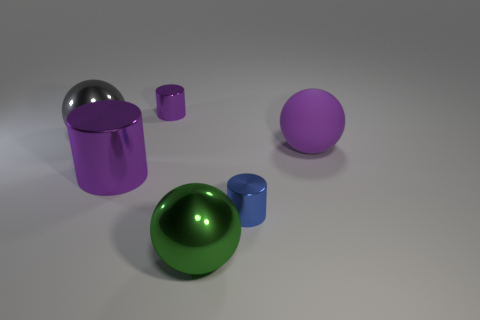Subtract all large green balls. How many balls are left? 2 Subtract all gray spheres. How many spheres are left? 2 Add 4 big purple things. How many objects exist? 10 Subtract 2 spheres. How many spheres are left? 1 Subtract all gray cubes. How many purple cylinders are left? 2 Add 4 tiny purple shiny cylinders. How many tiny purple shiny cylinders are left? 5 Add 1 purple matte objects. How many purple matte objects exist? 2 Subtract 0 red cubes. How many objects are left? 6 Subtract all gray balls. Subtract all red cubes. How many balls are left? 2 Subtract all large purple cylinders. Subtract all tiny purple shiny objects. How many objects are left? 4 